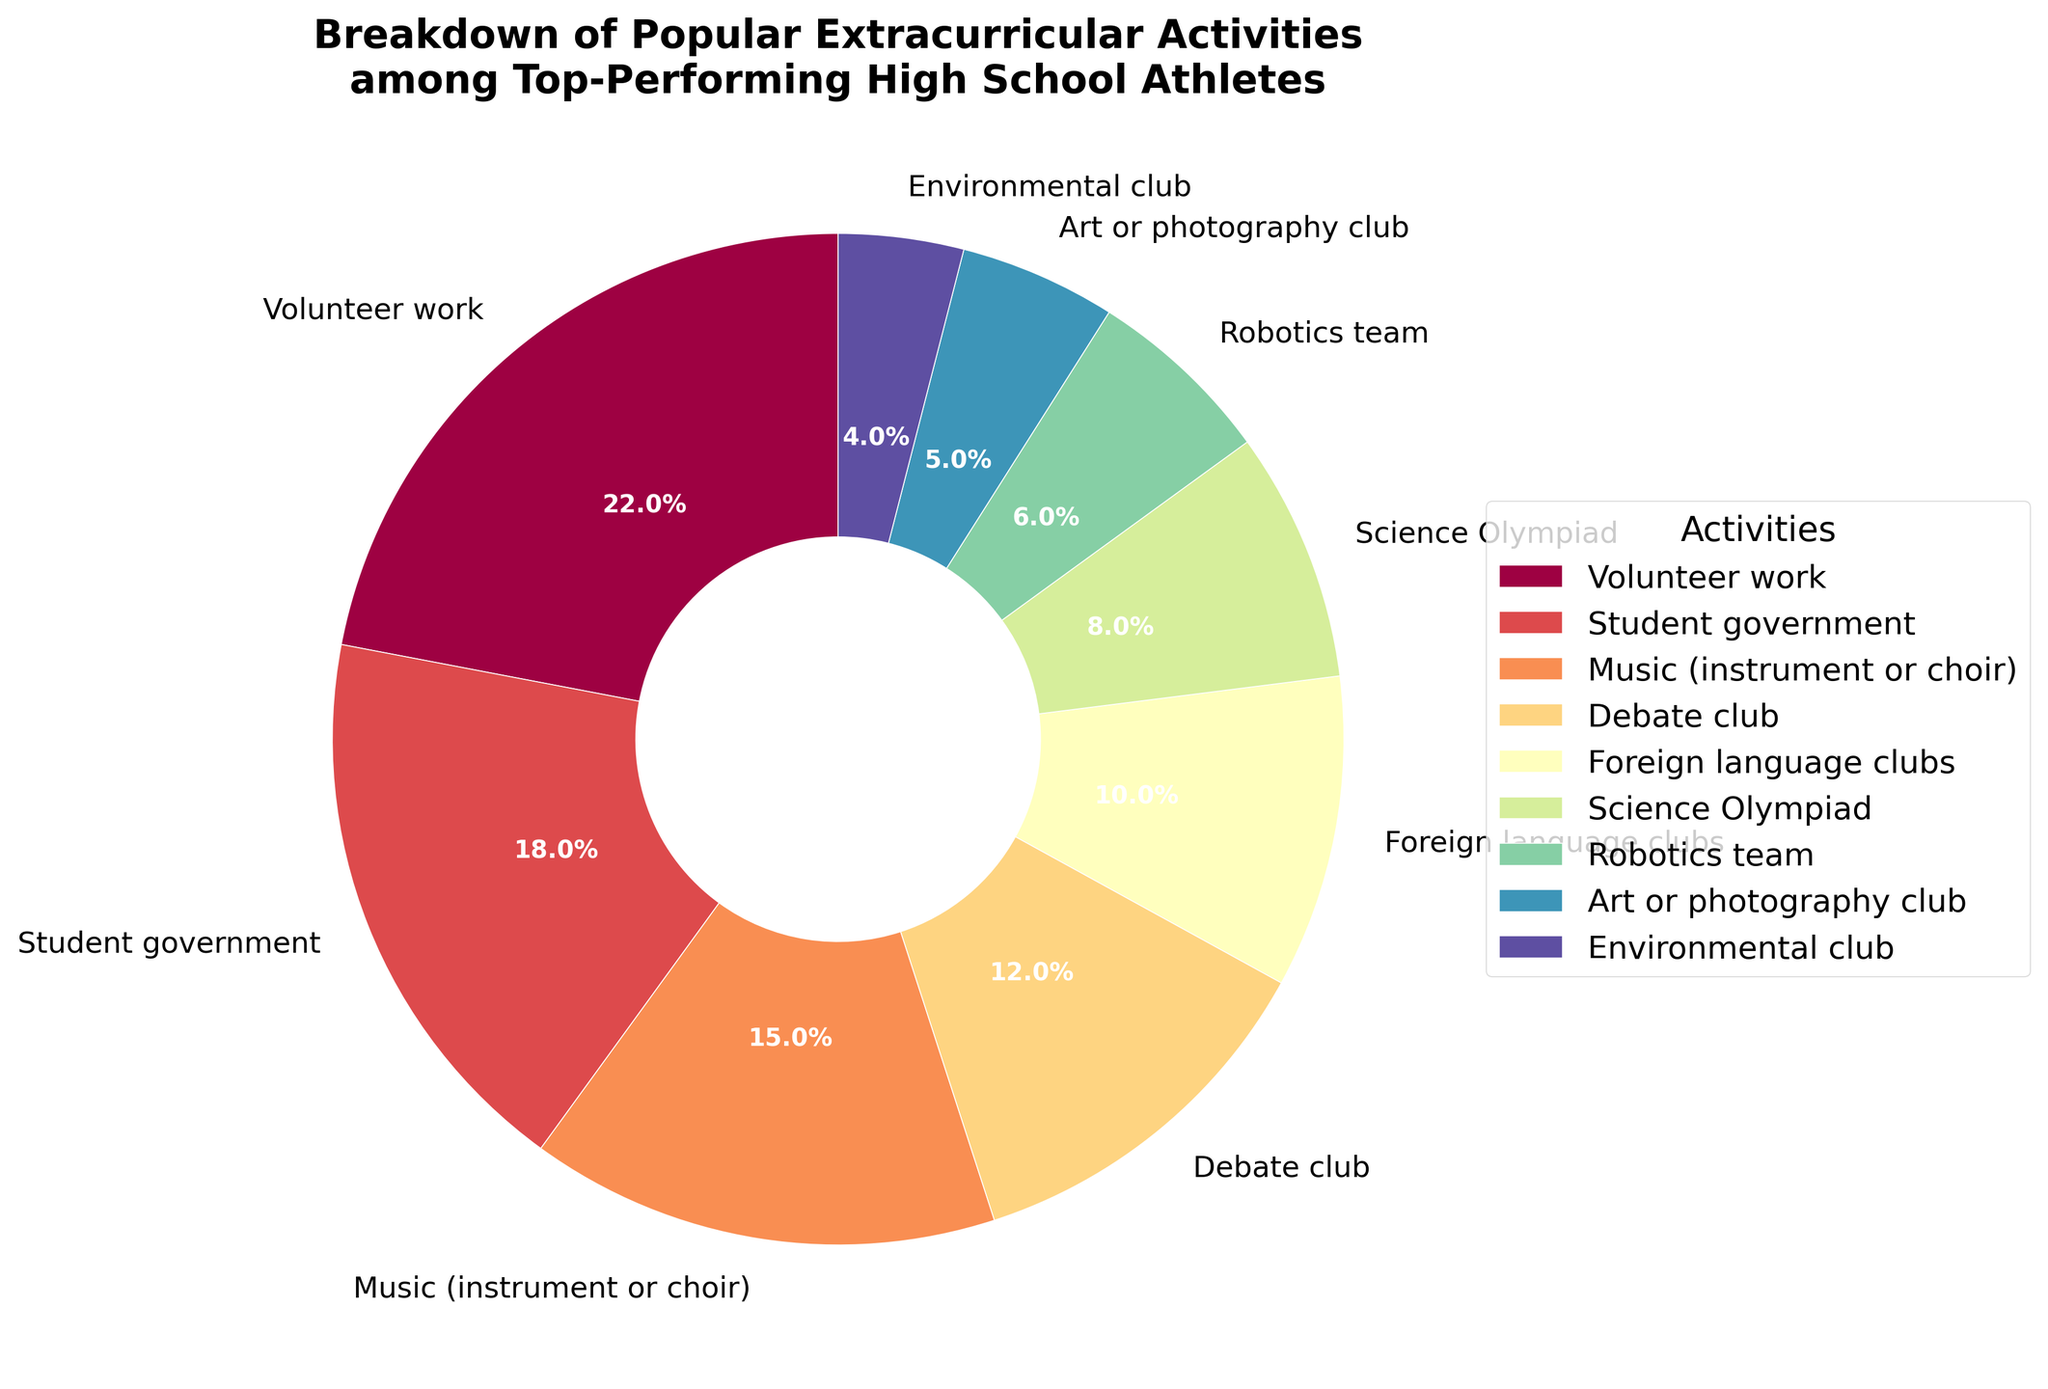Which activity has the highest percentage of participation? The activity with the largest segment in the pie chart is the one with the highest participation. Based on the data, Volunteer work holds the largest segment with a 22% share.
Answer: Volunteer work Which three activities combined have a total participation of 45%? To find this, look for the combination of three activities whose percentages sum to 45%. From the data, Music (15%) + Debate club (12%) + Foreign language clubs (10%) = 37%; however, Science Olympiad (8%) + Foreign language clubs (10%) + Robotics team (6%) = 24%. Therefore, Student government (18%) + Music (15%) + Debate club (12%) = 45%.
Answer: Student government, Music, Debate club How does the participation percentage of Science Olympiad compare to that of the Environmental club? Compare the two segments corresponding to Science Olympiad and Environmental club. The data shows Science Olympiad has 8% while Environmental club has 4%. Thus, Science Olympiad has a higher participation percentage.
Answer: Science Olympiad has a higher percentage What is the difference in participation percentage between Student government and Robotics team? Subtract the percentage of Robotics team from the percentage of Student government. Student government has 18% and Robotics team has 6%, so the difference is 18% - 6% = 12%.
Answer: 12% Are Music and Debate club combined participating more than Volunteer work? Add the percentages of Music and Debate club and compare it to Volunteer work. Music has 15%, Debate club has 12%, and their sum is 27%. Volunteer work is 22%. Since 27% > 22%, Music and Debate club combined hold a higher percentage.
Answer: Yes Which activity is represented with the segment that has a purple-like color? Look at the segment with a purple-like color in the pie chart. Based on common use of colors in pie charts, Science Olympiad often is given a purple-like color.
Answer: Science Olympiad What is the total percentage of activities related to science and technology (Science Olympiad and Robotics team) in the pie chart? Add the percentages of Science Olympiad and Robotics team. Science Olympiad has 8%, Robotics team has 6%, so the total is 8% + 6% = 14%.
Answer: 14% Which activity's participation is exactly double that of the Environmental club? Find the activity whose participation percentage is twice that of the Environmental club. Environmental club has 4%, so double that is 8%. Science Olympiad matches this percentage.
Answer: Science Olympiad 